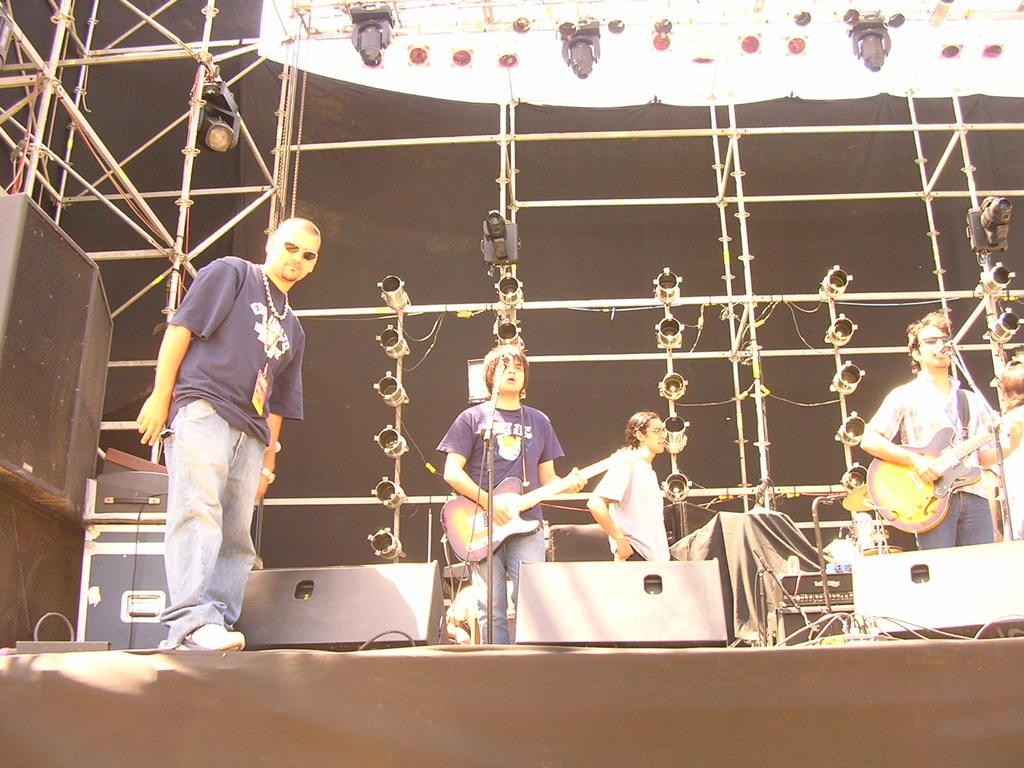What is happening in the image? There are people standing on a stage in the image. What are the people holding on the stage? Two people are holding guitars. What is in front of the people holding guitars? There is a microphone in front of the people holding guitars. What letter is being read by the actor in the image? There is no actor or letter present in the image; it features people holding guitars on a stage with a microphone. 